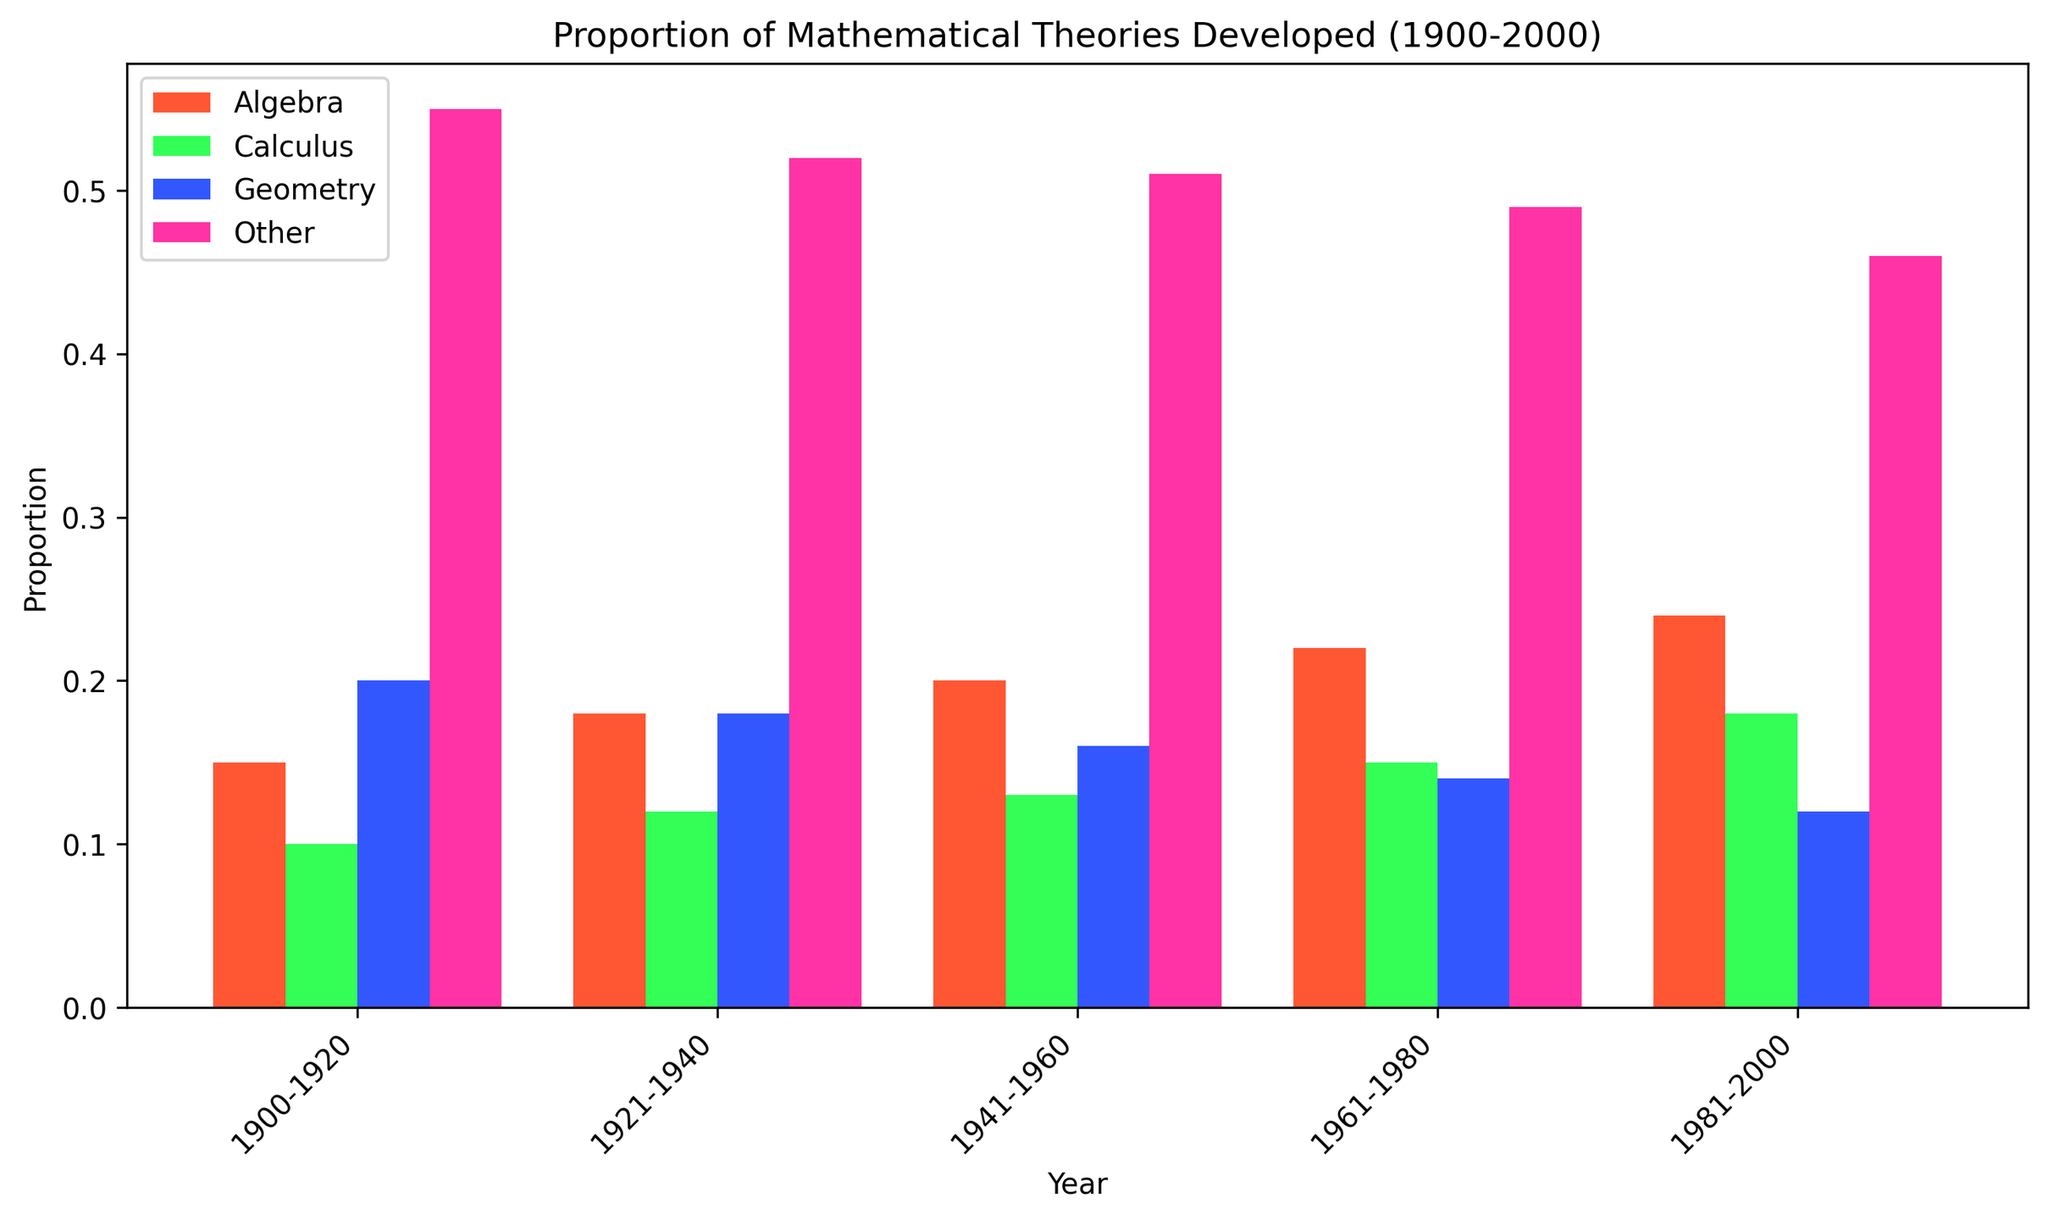What is the overall trend for the proportion of theories developed in Algebra from 1900 to 2000? To find the trend for Algebra, observe the bar heights for the periods 1900-1920, 1921-1940, 1941-1960, 1961-1980, and 1981-2000. The bar heights progressively increase, indicating a rising trend.
Answer: Rising Which branch saw a decline in the proportion of theories developed from 1900-2000? By examining the bar heights, it is clear that the proportion of theories developed in Geometry declined over the periods, as the bar heights decreased from 0.20 in 1900-1920 to 0.12 in 1981-2000.
Answer: Geometry How does the proportion of theories developed in Calculus in 1981-2000 compare to that in Algebra for the same period? Look at the bar heights for Calculus and Algebra in the period 1981-2000. The height for Calculus is shorter (0.18) compared to that for Algebra (0.24), indicating that Algebra had a higher proportion.
Answer: Algebra is higher What is the difference in the proportion of theories developed between Geometry and Calculus in 1941-1960? For 1941-1960, Geometry has a proportion of 0.16 and Calculus has 0.13. The difference is calculated by subtracting the lower proportion (0.13) from the higher (0.16), yielding 0.03.
Answer: 0.03 Which branch had the highest proportion of theories developed in the period 1900-1920? Compare the bar heights of all branches for 1900-1920. The 'Other' branch has the highest bar height at 0.55.
Answer: Other In which period did Algebra first surpass Calculus in the proportion of theories developed? Examine the bar heights of Algebra and Calculus across all periods. Algebra first surpasses Calculus during the period 1900-1920, where Algebra is at 0.15 and Calculus is at 0.10.
Answer: 1900-1920 What color represents the proportion of theories developed in Calculus? Look at the legend provided in the plot and match the color associated with Calculus. The color representing Calculus is green.
Answer: Green Calculate the average proportion of theories developed in Geometry across all periods. Combine all Geometry proportions (0.20, 0.18, 0.16, 0.14, 0.12), then sum them (0.80) and divide by the number of periods (5), yielding an average of 0.16.
Answer: 0.16 How much did the proportion of theories developed in 'Other' change from 1900-1920 to 1981-2000? Subtract the proportion of 'Other' in 1981-2000 (0.46) from the proportion in 1900-1920 (0.55), resulting in a decrease of 0.09.
Answer: Decrease by 0.09 Which branch has the smallest increase in proportion from 1900-1920 to 1981-2000? By comparing the initial and final proportions of all branches—Algebra, Calculus, Geometry, and Other—Geometry shows a decrease instead of an increase.
Answer: Geometry 